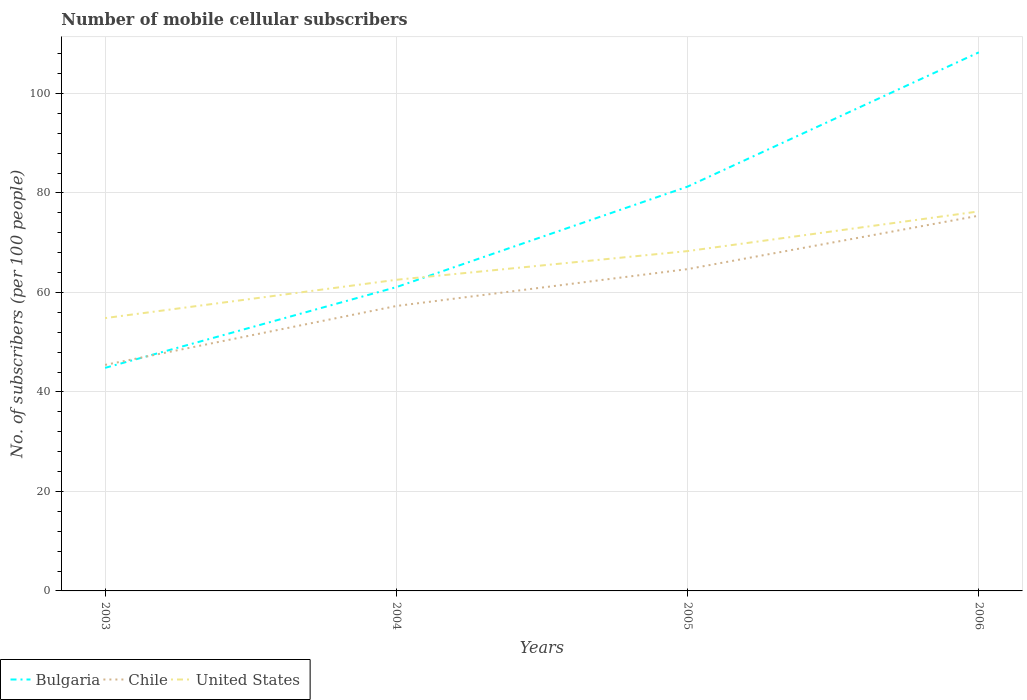Does the line corresponding to Bulgaria intersect with the line corresponding to United States?
Your response must be concise. Yes. Across all years, what is the maximum number of mobile cellular subscribers in Chile?
Ensure brevity in your answer.  45.44. In which year was the number of mobile cellular subscribers in Bulgaria maximum?
Offer a terse response. 2003. What is the total number of mobile cellular subscribers in Chile in the graph?
Your answer should be very brief. -11.84. What is the difference between the highest and the second highest number of mobile cellular subscribers in Bulgaria?
Your response must be concise. 63.43. What is the difference between the highest and the lowest number of mobile cellular subscribers in Chile?
Make the answer very short. 2. Is the number of mobile cellular subscribers in United States strictly greater than the number of mobile cellular subscribers in Bulgaria over the years?
Keep it short and to the point. No. How many years are there in the graph?
Keep it short and to the point. 4. What is the difference between two consecutive major ticks on the Y-axis?
Keep it short and to the point. 20. Where does the legend appear in the graph?
Your answer should be compact. Bottom left. How many legend labels are there?
Provide a succinct answer. 3. How are the legend labels stacked?
Your response must be concise. Horizontal. What is the title of the graph?
Make the answer very short. Number of mobile cellular subscribers. Does "Djibouti" appear as one of the legend labels in the graph?
Your answer should be compact. No. What is the label or title of the Y-axis?
Make the answer very short. No. of subscribers (per 100 people). What is the No. of subscribers (per 100 people) of Bulgaria in 2003?
Offer a terse response. 44.84. What is the No. of subscribers (per 100 people) of Chile in 2003?
Provide a succinct answer. 45.44. What is the No. of subscribers (per 100 people) of United States in 2003?
Give a very brief answer. 54.85. What is the No. of subscribers (per 100 people) of Bulgaria in 2004?
Provide a short and direct response. 61.07. What is the No. of subscribers (per 100 people) of Chile in 2004?
Give a very brief answer. 57.28. What is the No. of subscribers (per 100 people) in United States in 2004?
Give a very brief answer. 62.55. What is the No. of subscribers (per 100 people) of Bulgaria in 2005?
Your answer should be compact. 81.28. What is the No. of subscribers (per 100 people) in Chile in 2005?
Make the answer very short. 64.69. What is the No. of subscribers (per 100 people) of United States in 2005?
Provide a short and direct response. 68.32. What is the No. of subscribers (per 100 people) of Bulgaria in 2006?
Your answer should be very brief. 108.27. What is the No. of subscribers (per 100 people) in Chile in 2006?
Offer a terse response. 75.44. What is the No. of subscribers (per 100 people) of United States in 2006?
Ensure brevity in your answer.  76.29. Across all years, what is the maximum No. of subscribers (per 100 people) of Bulgaria?
Make the answer very short. 108.27. Across all years, what is the maximum No. of subscribers (per 100 people) in Chile?
Your response must be concise. 75.44. Across all years, what is the maximum No. of subscribers (per 100 people) in United States?
Keep it short and to the point. 76.29. Across all years, what is the minimum No. of subscribers (per 100 people) of Bulgaria?
Provide a succinct answer. 44.84. Across all years, what is the minimum No. of subscribers (per 100 people) of Chile?
Your answer should be very brief. 45.44. Across all years, what is the minimum No. of subscribers (per 100 people) of United States?
Give a very brief answer. 54.85. What is the total No. of subscribers (per 100 people) in Bulgaria in the graph?
Keep it short and to the point. 295.47. What is the total No. of subscribers (per 100 people) of Chile in the graph?
Offer a terse response. 242.85. What is the total No. of subscribers (per 100 people) in United States in the graph?
Provide a short and direct response. 262.01. What is the difference between the No. of subscribers (per 100 people) of Bulgaria in 2003 and that in 2004?
Give a very brief answer. -16.23. What is the difference between the No. of subscribers (per 100 people) in Chile in 2003 and that in 2004?
Give a very brief answer. -11.84. What is the difference between the No. of subscribers (per 100 people) in United States in 2003 and that in 2004?
Provide a succinct answer. -7.7. What is the difference between the No. of subscribers (per 100 people) of Bulgaria in 2003 and that in 2005?
Make the answer very short. -36.44. What is the difference between the No. of subscribers (per 100 people) in Chile in 2003 and that in 2005?
Your response must be concise. -19.26. What is the difference between the No. of subscribers (per 100 people) in United States in 2003 and that in 2005?
Offer a terse response. -13.47. What is the difference between the No. of subscribers (per 100 people) in Bulgaria in 2003 and that in 2006?
Offer a terse response. -63.43. What is the difference between the No. of subscribers (per 100 people) in Chile in 2003 and that in 2006?
Give a very brief answer. -30. What is the difference between the No. of subscribers (per 100 people) of United States in 2003 and that in 2006?
Offer a terse response. -21.45. What is the difference between the No. of subscribers (per 100 people) of Bulgaria in 2004 and that in 2005?
Your response must be concise. -20.21. What is the difference between the No. of subscribers (per 100 people) of Chile in 2004 and that in 2005?
Your answer should be very brief. -7.41. What is the difference between the No. of subscribers (per 100 people) of United States in 2004 and that in 2005?
Offer a terse response. -5.77. What is the difference between the No. of subscribers (per 100 people) of Bulgaria in 2004 and that in 2006?
Give a very brief answer. -47.2. What is the difference between the No. of subscribers (per 100 people) in Chile in 2004 and that in 2006?
Your answer should be compact. -18.16. What is the difference between the No. of subscribers (per 100 people) of United States in 2004 and that in 2006?
Keep it short and to the point. -13.75. What is the difference between the No. of subscribers (per 100 people) of Bulgaria in 2005 and that in 2006?
Keep it short and to the point. -26.99. What is the difference between the No. of subscribers (per 100 people) of Chile in 2005 and that in 2006?
Keep it short and to the point. -10.74. What is the difference between the No. of subscribers (per 100 people) of United States in 2005 and that in 2006?
Provide a succinct answer. -7.98. What is the difference between the No. of subscribers (per 100 people) in Bulgaria in 2003 and the No. of subscribers (per 100 people) in Chile in 2004?
Make the answer very short. -12.44. What is the difference between the No. of subscribers (per 100 people) of Bulgaria in 2003 and the No. of subscribers (per 100 people) of United States in 2004?
Offer a very short reply. -17.7. What is the difference between the No. of subscribers (per 100 people) in Chile in 2003 and the No. of subscribers (per 100 people) in United States in 2004?
Keep it short and to the point. -17.11. What is the difference between the No. of subscribers (per 100 people) of Bulgaria in 2003 and the No. of subscribers (per 100 people) of Chile in 2005?
Offer a terse response. -19.85. What is the difference between the No. of subscribers (per 100 people) in Bulgaria in 2003 and the No. of subscribers (per 100 people) in United States in 2005?
Your answer should be very brief. -23.48. What is the difference between the No. of subscribers (per 100 people) in Chile in 2003 and the No. of subscribers (per 100 people) in United States in 2005?
Ensure brevity in your answer.  -22.88. What is the difference between the No. of subscribers (per 100 people) in Bulgaria in 2003 and the No. of subscribers (per 100 people) in Chile in 2006?
Offer a very short reply. -30.6. What is the difference between the No. of subscribers (per 100 people) of Bulgaria in 2003 and the No. of subscribers (per 100 people) of United States in 2006?
Your response must be concise. -31.45. What is the difference between the No. of subscribers (per 100 people) of Chile in 2003 and the No. of subscribers (per 100 people) of United States in 2006?
Provide a succinct answer. -30.85. What is the difference between the No. of subscribers (per 100 people) of Bulgaria in 2004 and the No. of subscribers (per 100 people) of Chile in 2005?
Provide a short and direct response. -3.62. What is the difference between the No. of subscribers (per 100 people) in Bulgaria in 2004 and the No. of subscribers (per 100 people) in United States in 2005?
Your answer should be compact. -7.25. What is the difference between the No. of subscribers (per 100 people) of Chile in 2004 and the No. of subscribers (per 100 people) of United States in 2005?
Your answer should be compact. -11.04. What is the difference between the No. of subscribers (per 100 people) in Bulgaria in 2004 and the No. of subscribers (per 100 people) in Chile in 2006?
Your response must be concise. -14.37. What is the difference between the No. of subscribers (per 100 people) of Bulgaria in 2004 and the No. of subscribers (per 100 people) of United States in 2006?
Ensure brevity in your answer.  -15.22. What is the difference between the No. of subscribers (per 100 people) in Chile in 2004 and the No. of subscribers (per 100 people) in United States in 2006?
Offer a terse response. -19.01. What is the difference between the No. of subscribers (per 100 people) in Bulgaria in 2005 and the No. of subscribers (per 100 people) in Chile in 2006?
Provide a short and direct response. 5.84. What is the difference between the No. of subscribers (per 100 people) in Bulgaria in 2005 and the No. of subscribers (per 100 people) in United States in 2006?
Your answer should be compact. 4.99. What is the difference between the No. of subscribers (per 100 people) of Chile in 2005 and the No. of subscribers (per 100 people) of United States in 2006?
Your answer should be very brief. -11.6. What is the average No. of subscribers (per 100 people) of Bulgaria per year?
Your response must be concise. 73.87. What is the average No. of subscribers (per 100 people) in Chile per year?
Give a very brief answer. 60.71. What is the average No. of subscribers (per 100 people) of United States per year?
Provide a short and direct response. 65.5. In the year 2003, what is the difference between the No. of subscribers (per 100 people) of Bulgaria and No. of subscribers (per 100 people) of Chile?
Offer a terse response. -0.6. In the year 2003, what is the difference between the No. of subscribers (per 100 people) in Bulgaria and No. of subscribers (per 100 people) in United States?
Provide a short and direct response. -10. In the year 2003, what is the difference between the No. of subscribers (per 100 people) in Chile and No. of subscribers (per 100 people) in United States?
Ensure brevity in your answer.  -9.41. In the year 2004, what is the difference between the No. of subscribers (per 100 people) of Bulgaria and No. of subscribers (per 100 people) of Chile?
Offer a terse response. 3.79. In the year 2004, what is the difference between the No. of subscribers (per 100 people) of Bulgaria and No. of subscribers (per 100 people) of United States?
Offer a terse response. -1.48. In the year 2004, what is the difference between the No. of subscribers (per 100 people) of Chile and No. of subscribers (per 100 people) of United States?
Give a very brief answer. -5.27. In the year 2005, what is the difference between the No. of subscribers (per 100 people) of Bulgaria and No. of subscribers (per 100 people) of Chile?
Your answer should be very brief. 16.59. In the year 2005, what is the difference between the No. of subscribers (per 100 people) in Bulgaria and No. of subscribers (per 100 people) in United States?
Your response must be concise. 12.96. In the year 2005, what is the difference between the No. of subscribers (per 100 people) of Chile and No. of subscribers (per 100 people) of United States?
Your answer should be compact. -3.62. In the year 2006, what is the difference between the No. of subscribers (per 100 people) in Bulgaria and No. of subscribers (per 100 people) in Chile?
Make the answer very short. 32.83. In the year 2006, what is the difference between the No. of subscribers (per 100 people) of Bulgaria and No. of subscribers (per 100 people) of United States?
Your answer should be compact. 31.98. In the year 2006, what is the difference between the No. of subscribers (per 100 people) of Chile and No. of subscribers (per 100 people) of United States?
Offer a terse response. -0.85. What is the ratio of the No. of subscribers (per 100 people) of Bulgaria in 2003 to that in 2004?
Provide a short and direct response. 0.73. What is the ratio of the No. of subscribers (per 100 people) in Chile in 2003 to that in 2004?
Your response must be concise. 0.79. What is the ratio of the No. of subscribers (per 100 people) in United States in 2003 to that in 2004?
Your answer should be compact. 0.88. What is the ratio of the No. of subscribers (per 100 people) in Bulgaria in 2003 to that in 2005?
Give a very brief answer. 0.55. What is the ratio of the No. of subscribers (per 100 people) in Chile in 2003 to that in 2005?
Your response must be concise. 0.7. What is the ratio of the No. of subscribers (per 100 people) of United States in 2003 to that in 2005?
Your answer should be very brief. 0.8. What is the ratio of the No. of subscribers (per 100 people) of Bulgaria in 2003 to that in 2006?
Make the answer very short. 0.41. What is the ratio of the No. of subscribers (per 100 people) in Chile in 2003 to that in 2006?
Offer a terse response. 0.6. What is the ratio of the No. of subscribers (per 100 people) in United States in 2003 to that in 2006?
Your answer should be very brief. 0.72. What is the ratio of the No. of subscribers (per 100 people) in Bulgaria in 2004 to that in 2005?
Your response must be concise. 0.75. What is the ratio of the No. of subscribers (per 100 people) in Chile in 2004 to that in 2005?
Provide a short and direct response. 0.89. What is the ratio of the No. of subscribers (per 100 people) of United States in 2004 to that in 2005?
Your answer should be compact. 0.92. What is the ratio of the No. of subscribers (per 100 people) of Bulgaria in 2004 to that in 2006?
Keep it short and to the point. 0.56. What is the ratio of the No. of subscribers (per 100 people) in Chile in 2004 to that in 2006?
Provide a short and direct response. 0.76. What is the ratio of the No. of subscribers (per 100 people) in United States in 2004 to that in 2006?
Make the answer very short. 0.82. What is the ratio of the No. of subscribers (per 100 people) in Bulgaria in 2005 to that in 2006?
Your answer should be compact. 0.75. What is the ratio of the No. of subscribers (per 100 people) of Chile in 2005 to that in 2006?
Make the answer very short. 0.86. What is the ratio of the No. of subscribers (per 100 people) in United States in 2005 to that in 2006?
Your response must be concise. 0.9. What is the difference between the highest and the second highest No. of subscribers (per 100 people) of Bulgaria?
Give a very brief answer. 26.99. What is the difference between the highest and the second highest No. of subscribers (per 100 people) in Chile?
Ensure brevity in your answer.  10.74. What is the difference between the highest and the second highest No. of subscribers (per 100 people) of United States?
Ensure brevity in your answer.  7.98. What is the difference between the highest and the lowest No. of subscribers (per 100 people) in Bulgaria?
Make the answer very short. 63.43. What is the difference between the highest and the lowest No. of subscribers (per 100 people) in Chile?
Give a very brief answer. 30. What is the difference between the highest and the lowest No. of subscribers (per 100 people) in United States?
Provide a short and direct response. 21.45. 